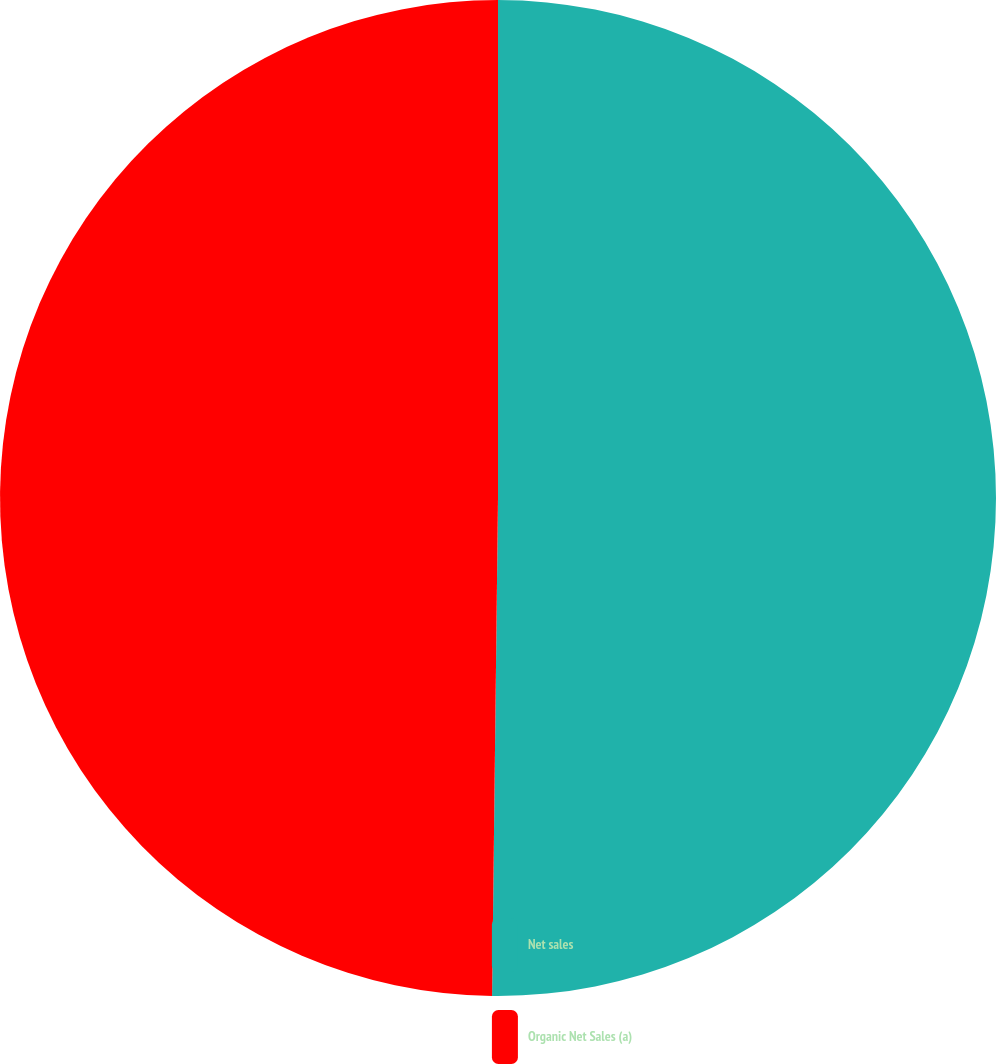Convert chart. <chart><loc_0><loc_0><loc_500><loc_500><pie_chart><fcel>Net sales<fcel>Organic Net Sales (a)<nl><fcel>50.19%<fcel>49.81%<nl></chart> 